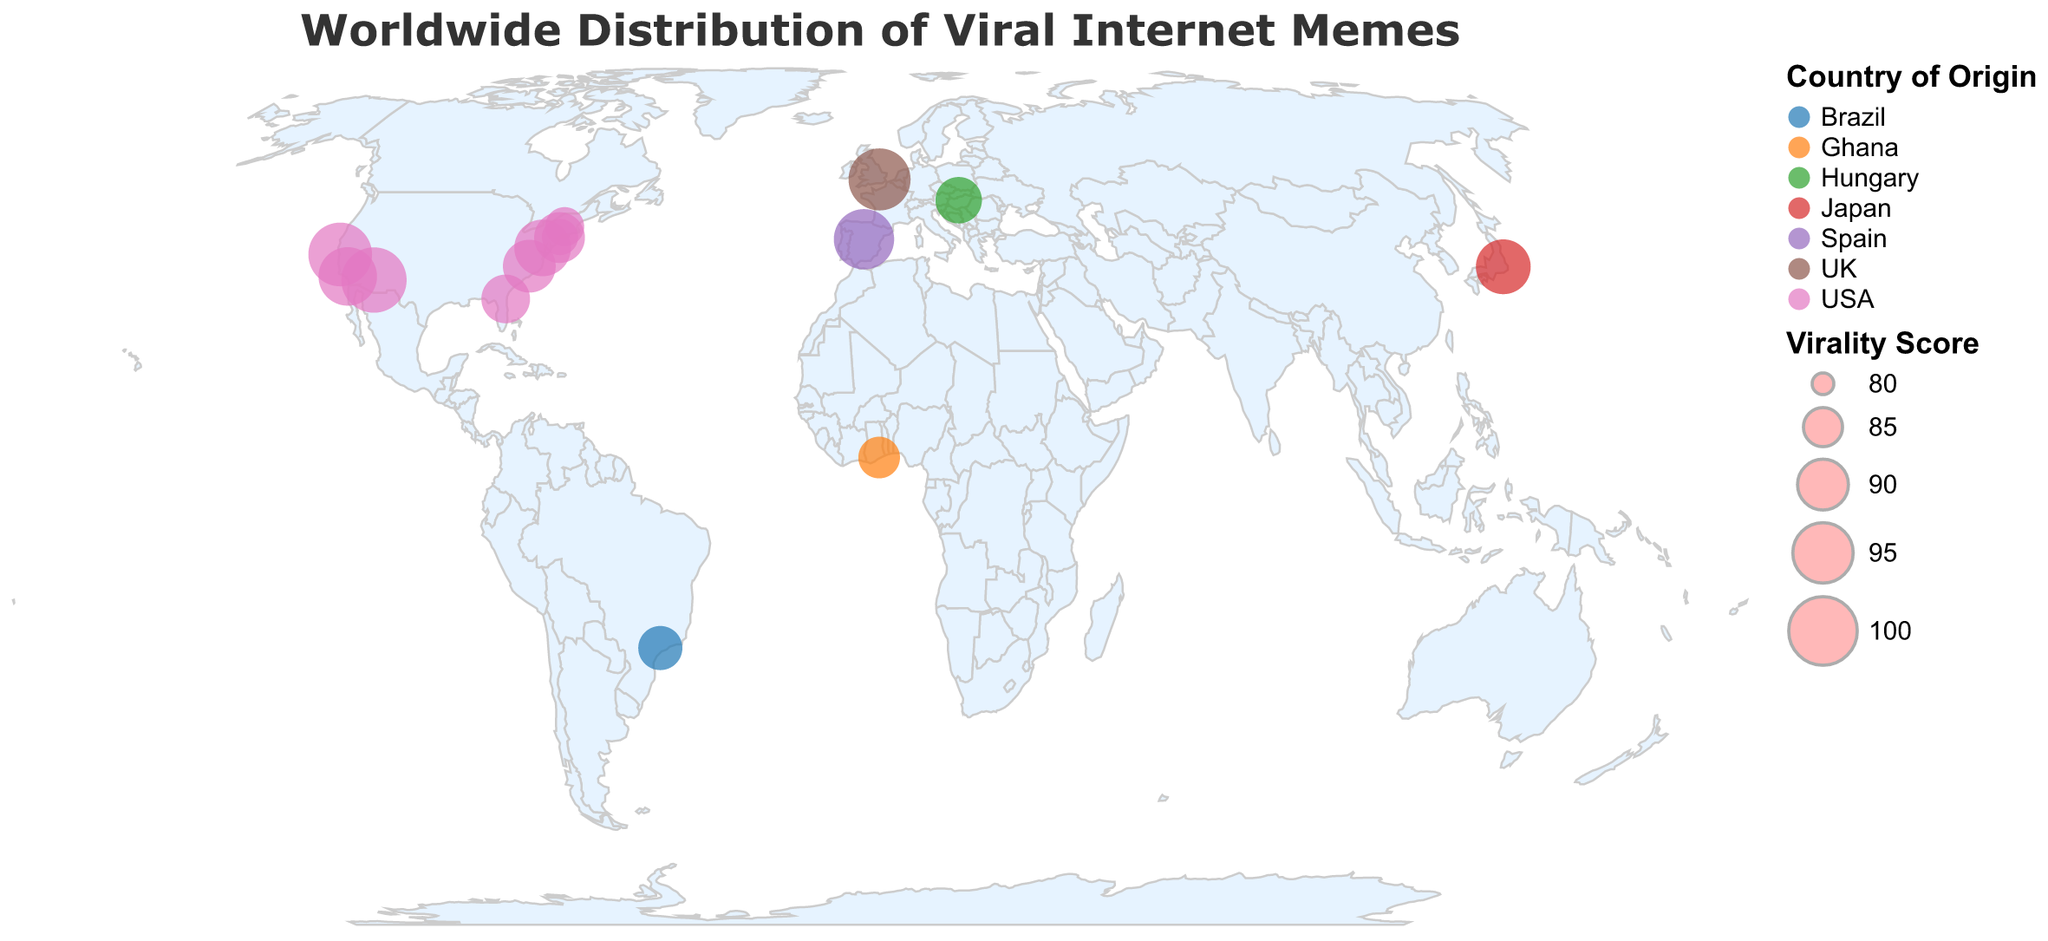What is the title of the figure? The title is usually displayed at the top of the figure in larger font. It provides a brief description of what the figure represents.
Answer: Worldwide Distribution of Viral Internet Memes How many memes originated from the USA? To answer this, count the circles on the map that are color-coded for the USA, as noted in the legend.
Answer: 9 Which meme has the highest virality score, and what is its score? By examining the legend and the points on the map, find the circle with the largest size (indicating the highest virality score). Hovering over the point can show details.
Answer: Grumpy Cat, 98 Which meme is the most viral outside of the USA? Look for the largest circles not located in the USA and check their information.
Answer: Rickroll, 96 What is the average virality score of all internet memes? Add up all the virality scores and divide by the number of memes. (95+98+92+88+97+91+89+96+87+93+90+94+86+85+84)/15 = 90.4
Answer: 90.4 Which continents have originated multiple viral internet memes? Identify the continents (North America, Europe, Asia, South America, Africa) in the figure and count how many memes originate from each. Europe: 2, North America: 9, Asia: 1, South America: 1, Africa: 1.
Answer: North America, Europe What is the difference in virality scores between 'Grumpy Cat' and 'Harlem Shake'? Subtract the virality score of 'Harlem Shake' from that of 'Grumpy Cat'. (98 - 84).
Answer: 14 Which country is the origin of 'Doge'? Look for the circle representing 'Doge' and check the tooltip information.
Answer: Japan What is the median virality score of all memes originating from the USA? List the scores of the US memes, order them, and find the middle value. Ordered Scores: 84, 85, 86, 89, 90, 91, 93, 94, 97, 98. Median = (91+93)/2 = 92.
Answer: 92 How many memes have a virality score greater than 90? Count the circles on the map that have a virality score above 90.
Answer: 9 